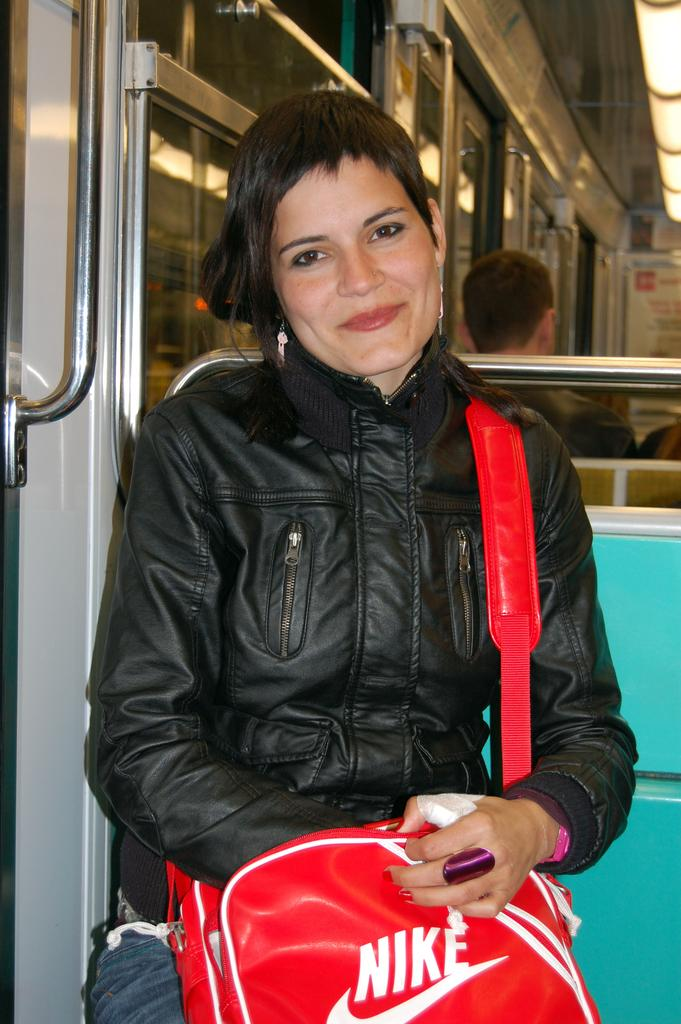Provide a one-sentence caption for the provided image. The woman on the bus had a red Nike bag. 